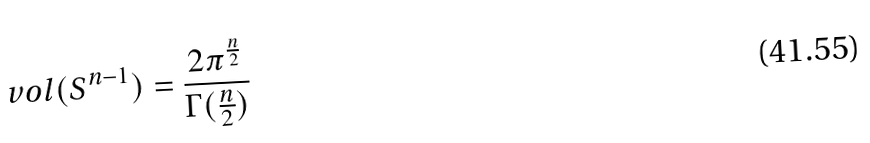Convert formula to latex. <formula><loc_0><loc_0><loc_500><loc_500>v o l ( S ^ { n - 1 } ) = \frac { 2 \pi ^ { \frac { n } { 2 } } } { \Gamma ( \frac { n } { 2 } ) }</formula> 